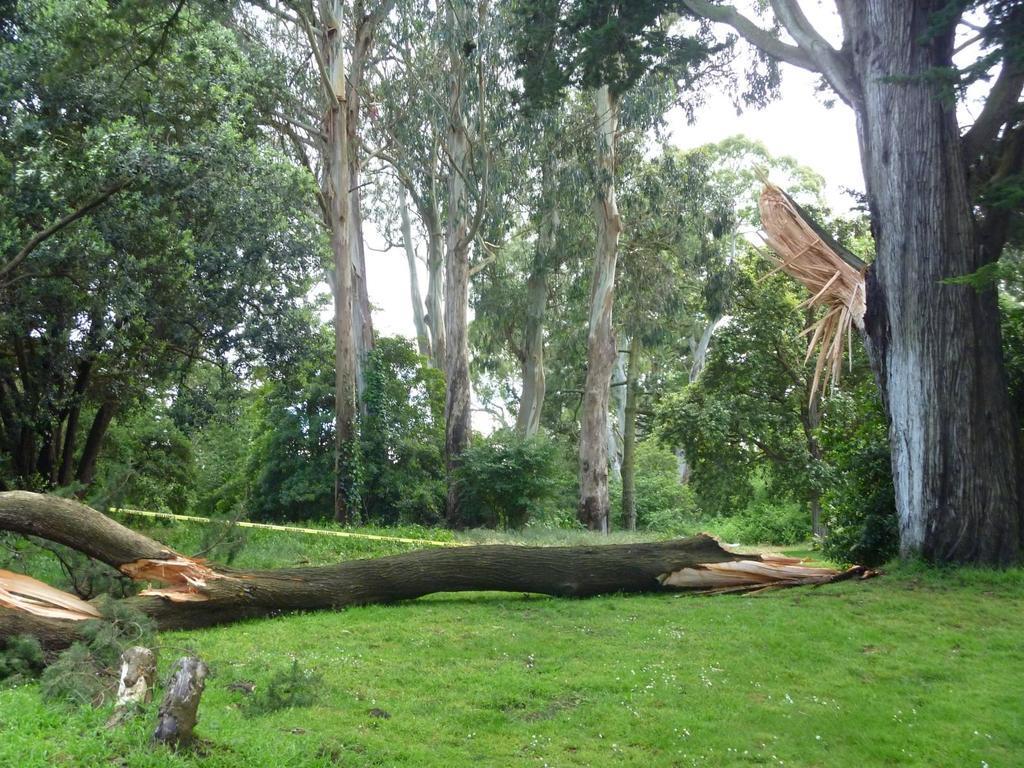Please provide a concise description of this image. This picture shows the view of the forest. In the front we can see a broken tree trunk lying on the ground. Behind we can see many huge trees. 